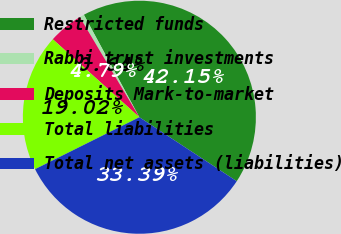<chart> <loc_0><loc_0><loc_500><loc_500><pie_chart><fcel>Restricted funds<fcel>Rabbi trust investments<fcel>Deposits Mark-to-market<fcel>Total liabilities<fcel>Total net assets (liabilities)<nl><fcel>42.15%<fcel>0.64%<fcel>4.79%<fcel>19.02%<fcel>33.39%<nl></chart> 